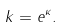Convert formula to latex. <formula><loc_0><loc_0><loc_500><loc_500>k = e ^ { \kappa } .</formula> 